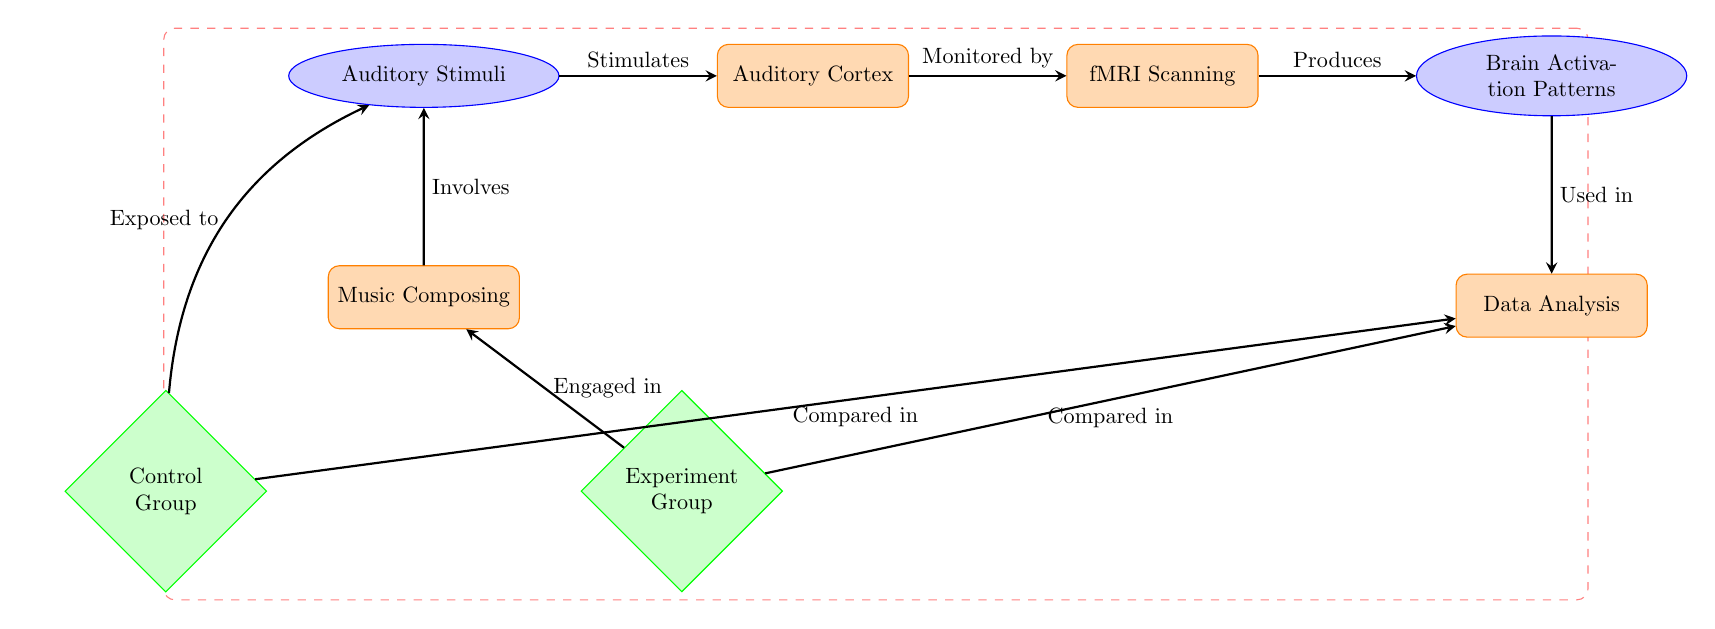What stimulates the Auditory Cortex? The diagram shows an arrow labeled "Stimulates" pointing from "Auditory Stimuli" to "Auditory Cortex," indicating that auditory stimuli are the input that activates the auditory cortex.
Answer: Auditory Stimuli What is monitored by fMRI? The diagram features a flow from "Auditory Cortex" to "fMRI Scanning" with the label "Monitored by." This indicates that the auditory cortex is the region being monitored during the scanning process.
Answer: Auditory Cortex How many groups are compared in the Data Analysis? The diagram indicates two groups: "Control Group" and "Experiment Group," which are shown connected to "Data Analysis" with the label "Compared in." Thus, there are two groups being analyzed.
Answer: Two Which process involves auditory stimuli? The diagram illustrates an arrow from "Music Composing" to "Auditory Stimuli" labeled "Involves," which indicates that music composing is the process that requires or involves auditory stimuli.
Answer: Music Composing What is used in Data Analysis after fMRI scanning? The diagram shows an arrow leading from "Brain Activation Patterns" to "Data Analysis" labeled "Used in." This indicates that the brain activation patterns obtained from fMRI are used during the data analysis phase.
Answer: Brain Activation Patterns What action is taken by the Experiment Group? An arrow labeled "Engaged in" leads from "Experiment Group" to "Music Composing," indicating that the experiment group is engaged in the process of composing music.
Answer: Engaged in Which group was exposed to auditory stimuli? The diagram shows an arrow labeled "Exposed to" leading from "Control Group" to "Auditory Stimuli," suggesting that the control group was exposed to auditory stimuli as part of their comparison.
Answer: Control Group What activates the "fMRI Scanning" node? The flow indicates that "Auditory Cortex" connects to "fMRI Scanning," labeled as "Monitored by." This suggests that the activation and monitoring of the auditory cortex are the factors that trigger the fMRI scanning process.
Answer: Auditory Cortex In which part of the diagram is the data analysis located? The "Data Analysis" node is located at the bottom section of the diagram, showing its position as the final process after brain activation patterns.
Answer: Bottom section 